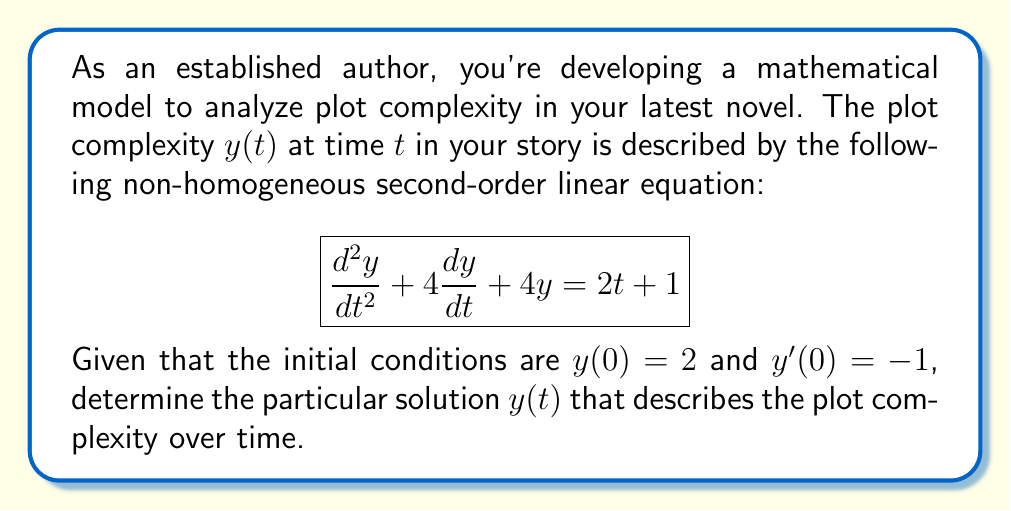Can you solve this math problem? To solve this non-homogeneous second-order linear equation, we'll follow these steps:

1) First, find the general solution of the homogeneous equation:
   $$\frac{d^2y}{dt^2} + 4\frac{dy}{dt} + 4y = 0$$
   The characteristic equation is $r^2 + 4r + 4 = 0$
   Solving this: $(r + 2)^2 = 0$, so $r = -2$ (repeated root)
   The homogeneous solution is: $y_h = (c_1 + c_2t)e^{-2t}$

2) Next, find a particular solution of the non-homogeneous equation:
   Try $y_p = At + B$ (since the right side is linear in t)
   $y_p' = A$
   $y_p'' = 0$
   Substituting into the original equation:
   $0 + 4A + 4(At + B) = 2t + 1$
   Equating coefficients:
   $4A = 2$, so $A = \frac{1}{2}$
   $4B + 4A = 1$, so $4B + 2 = 1$, $B = -\frac{1}{4}$
   Thus, $y_p = \frac{1}{2}t - \frac{1}{4}$

3) The general solution is $y = y_h + y_p$:
   $y = (c_1 + c_2t)e^{-2t} + \frac{1}{2}t - \frac{1}{4}$

4) Use the initial conditions to find $c_1$ and $c_2$:
   $y(0) = 2$: $c_1 - \frac{1}{4} = 2$, so $c_1 = \frac{9}{4}$
   $y'(0) = -1$: $-2c_1 + c_2 + \frac{1}{2} = -1$
   Substituting $c_1$: $-\frac{9}{2} + c_2 + \frac{1}{2} = -1$
   Solving: $c_2 = 4$

5) The particular solution is therefore:
   $y(t) = (\frac{9}{4} + 4t)e^{-2t} + \frac{1}{2}t - \frac{1}{4}$
Answer: $y(t) = (\frac{9}{4} + 4t)e^{-2t} + \frac{1}{2}t - \frac{1}{4}$ 